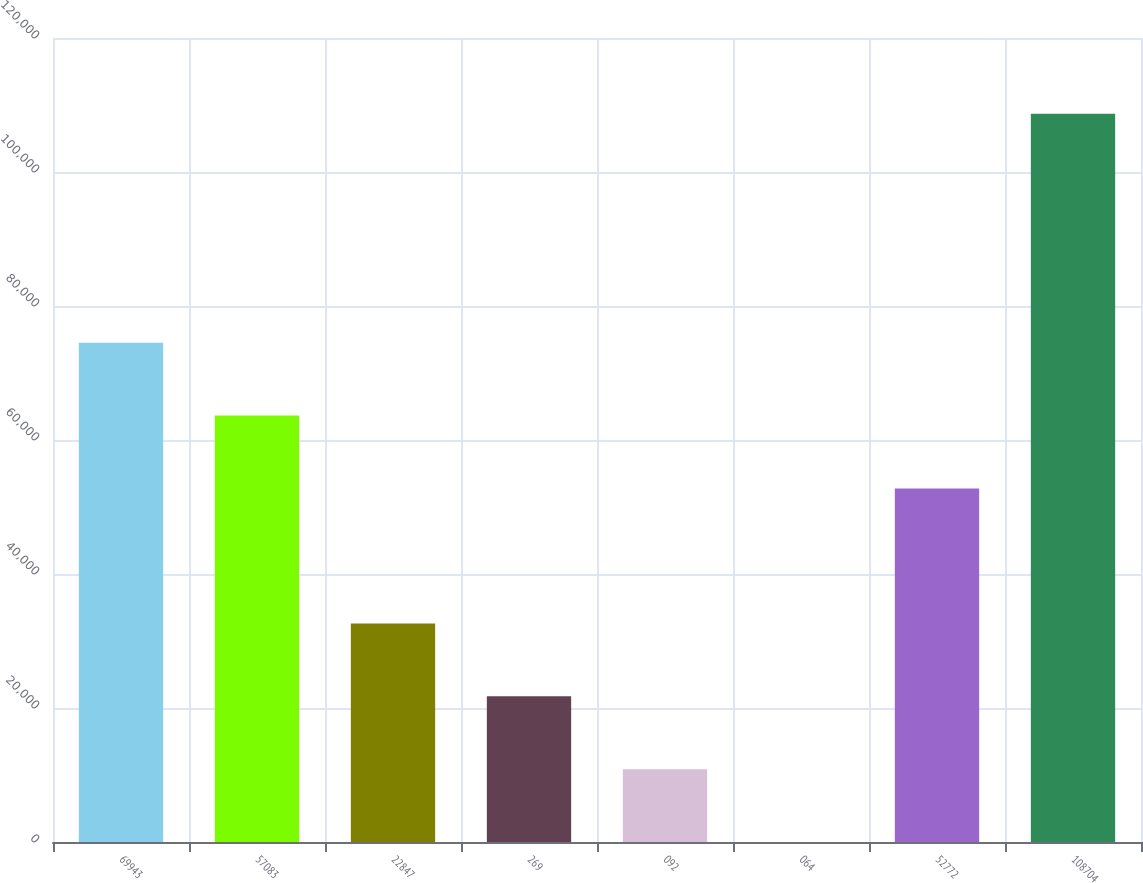Convert chart to OTSL. <chart><loc_0><loc_0><loc_500><loc_500><bar_chart><fcel>69943<fcel>57083<fcel>22847<fcel>269<fcel>092<fcel>064<fcel>52772<fcel>108704<nl><fcel>74512.7<fcel>63642.3<fcel>32611.7<fcel>21741.3<fcel>10871<fcel>0.64<fcel>52772<fcel>108704<nl></chart> 